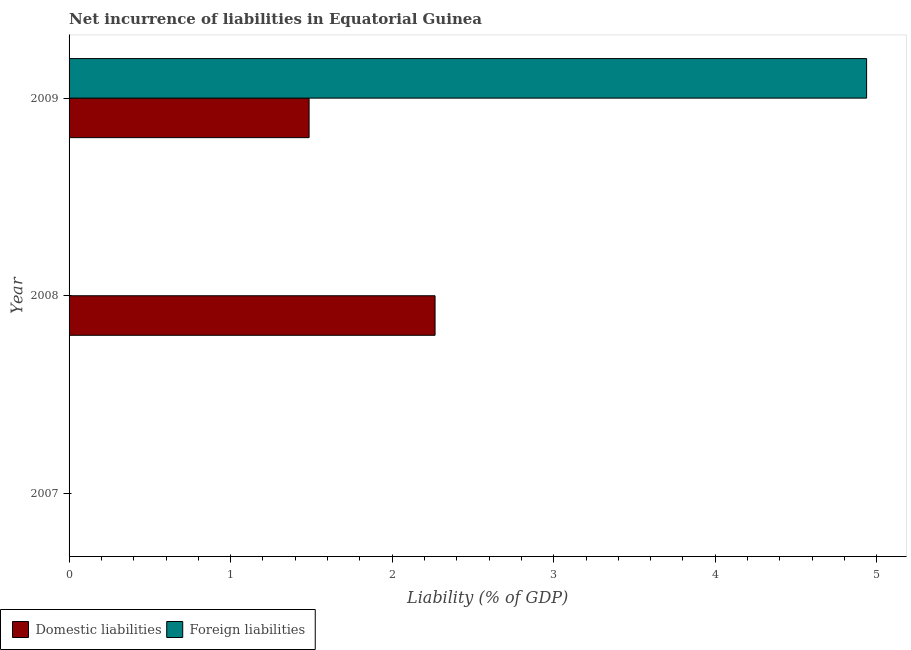How many different coloured bars are there?
Keep it short and to the point. 2. Are the number of bars on each tick of the Y-axis equal?
Keep it short and to the point. No. What is the label of the 1st group of bars from the top?
Make the answer very short. 2009. What is the incurrence of foreign liabilities in 2008?
Make the answer very short. 0. Across all years, what is the maximum incurrence of foreign liabilities?
Provide a succinct answer. 4.94. Across all years, what is the minimum incurrence of foreign liabilities?
Your answer should be very brief. 0. What is the total incurrence of domestic liabilities in the graph?
Your response must be concise. 3.75. What is the difference between the incurrence of domestic liabilities in 2008 and that in 2009?
Your response must be concise. 0.78. What is the difference between the incurrence of foreign liabilities in 2007 and the incurrence of domestic liabilities in 2009?
Your answer should be compact. -1.49. In the year 2009, what is the difference between the incurrence of foreign liabilities and incurrence of domestic liabilities?
Offer a very short reply. 3.45. In how many years, is the incurrence of domestic liabilities greater than 2 %?
Provide a succinct answer. 1. What is the ratio of the incurrence of domestic liabilities in 2008 to that in 2009?
Provide a short and direct response. 1.52. What is the difference between the highest and the lowest incurrence of foreign liabilities?
Offer a very short reply. 4.94. Is the sum of the incurrence of domestic liabilities in 2008 and 2009 greater than the maximum incurrence of foreign liabilities across all years?
Your response must be concise. No. What is the difference between two consecutive major ticks on the X-axis?
Give a very brief answer. 1. Does the graph contain grids?
Provide a succinct answer. No. How many legend labels are there?
Your response must be concise. 2. How are the legend labels stacked?
Offer a terse response. Horizontal. What is the title of the graph?
Your response must be concise. Net incurrence of liabilities in Equatorial Guinea. Does "Public funds" appear as one of the legend labels in the graph?
Provide a short and direct response. No. What is the label or title of the X-axis?
Ensure brevity in your answer.  Liability (% of GDP). What is the label or title of the Y-axis?
Your answer should be compact. Year. What is the Liability (% of GDP) of Domestic liabilities in 2007?
Offer a terse response. 0. What is the Liability (% of GDP) in Foreign liabilities in 2007?
Give a very brief answer. 0. What is the Liability (% of GDP) in Domestic liabilities in 2008?
Provide a short and direct response. 2.27. What is the Liability (% of GDP) of Domestic liabilities in 2009?
Provide a succinct answer. 1.49. What is the Liability (% of GDP) of Foreign liabilities in 2009?
Ensure brevity in your answer.  4.94. Across all years, what is the maximum Liability (% of GDP) in Domestic liabilities?
Make the answer very short. 2.27. Across all years, what is the maximum Liability (% of GDP) in Foreign liabilities?
Your response must be concise. 4.94. Across all years, what is the minimum Liability (% of GDP) in Domestic liabilities?
Provide a short and direct response. 0. Across all years, what is the minimum Liability (% of GDP) in Foreign liabilities?
Your response must be concise. 0. What is the total Liability (% of GDP) in Domestic liabilities in the graph?
Your response must be concise. 3.75. What is the total Liability (% of GDP) in Foreign liabilities in the graph?
Offer a terse response. 4.94. What is the difference between the Liability (% of GDP) of Domestic liabilities in 2008 and that in 2009?
Your response must be concise. 0.78. What is the difference between the Liability (% of GDP) of Domestic liabilities in 2008 and the Liability (% of GDP) of Foreign liabilities in 2009?
Ensure brevity in your answer.  -2.67. What is the average Liability (% of GDP) in Domestic liabilities per year?
Offer a very short reply. 1.25. What is the average Liability (% of GDP) of Foreign liabilities per year?
Offer a terse response. 1.65. In the year 2009, what is the difference between the Liability (% of GDP) of Domestic liabilities and Liability (% of GDP) of Foreign liabilities?
Offer a very short reply. -3.45. What is the ratio of the Liability (% of GDP) of Domestic liabilities in 2008 to that in 2009?
Offer a terse response. 1.52. What is the difference between the highest and the lowest Liability (% of GDP) of Domestic liabilities?
Ensure brevity in your answer.  2.27. What is the difference between the highest and the lowest Liability (% of GDP) of Foreign liabilities?
Your answer should be very brief. 4.94. 